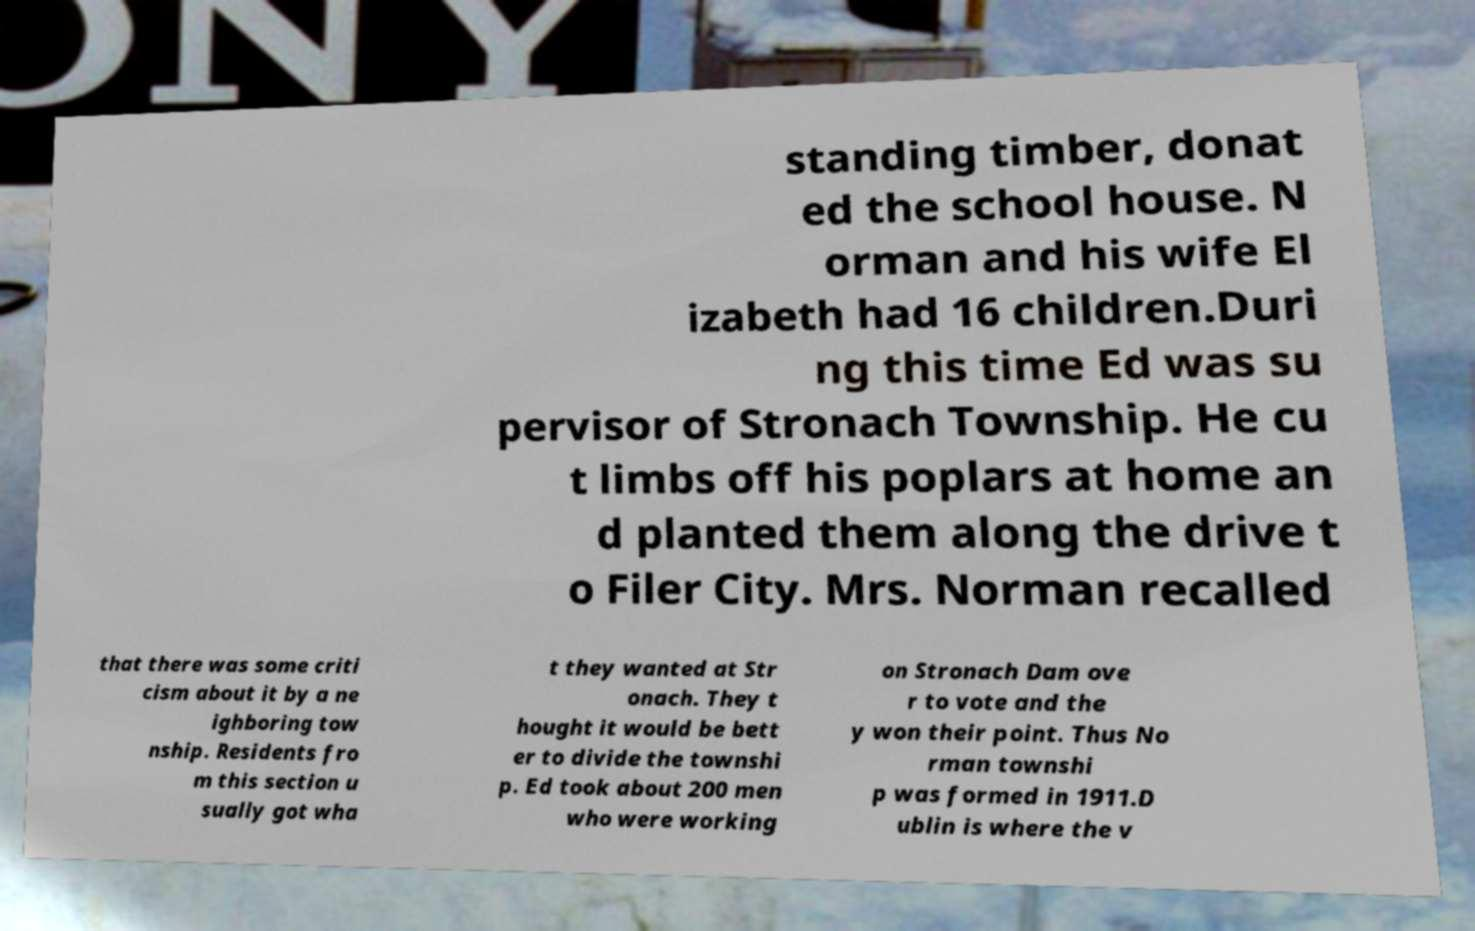Please identify and transcribe the text found in this image. standing timber, donat ed the school house. N orman and his wife El izabeth had 16 children.Duri ng this time Ed was su pervisor of Stronach Township. He cu t limbs off his poplars at home an d planted them along the drive t o Filer City. Mrs. Norman recalled that there was some criti cism about it by a ne ighboring tow nship. Residents fro m this section u sually got wha t they wanted at Str onach. They t hought it would be bett er to divide the townshi p. Ed took about 200 men who were working on Stronach Dam ove r to vote and the y won their point. Thus No rman townshi p was formed in 1911.D ublin is where the v 